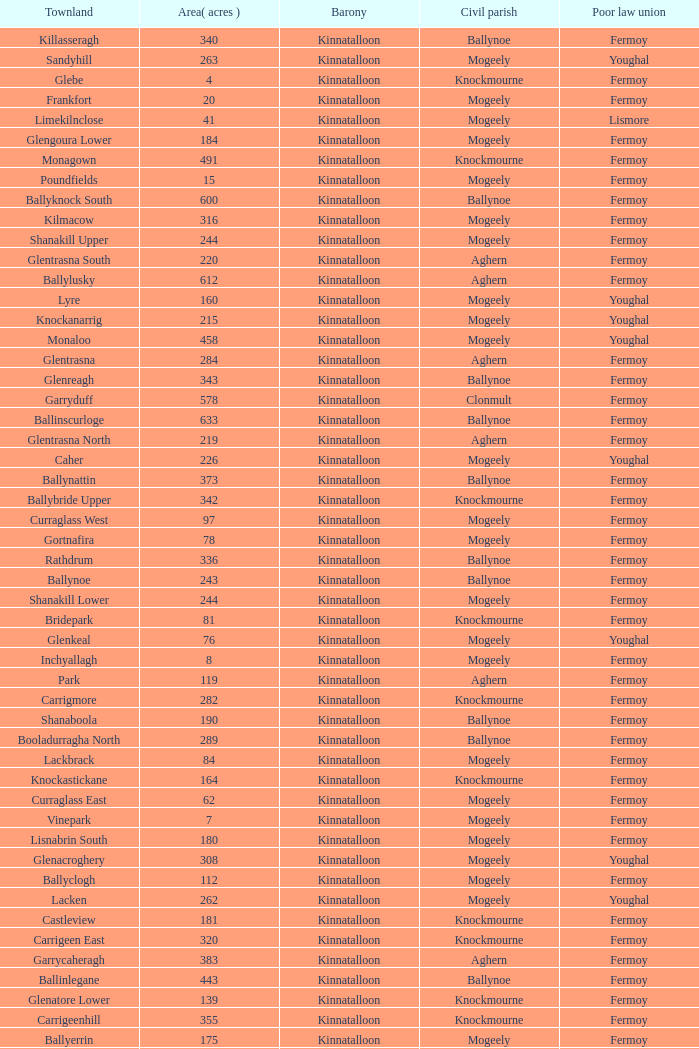Name  the townland for fermoy and ballynoe Ballinlegane, Ballinscurloge, Ballyknock, Ballyknock North, Ballyknock South, Ballymonteen, Ballynattin, Ballynoe, Booladurragha North, Booladurragha South, Cullenagh, Garraneribbeen, Glenreagh, Glentane, Killasseragh, Kilphillibeen, Knockakeo, Longueville North, Longueville South, Rathdrum, Shanaboola. 